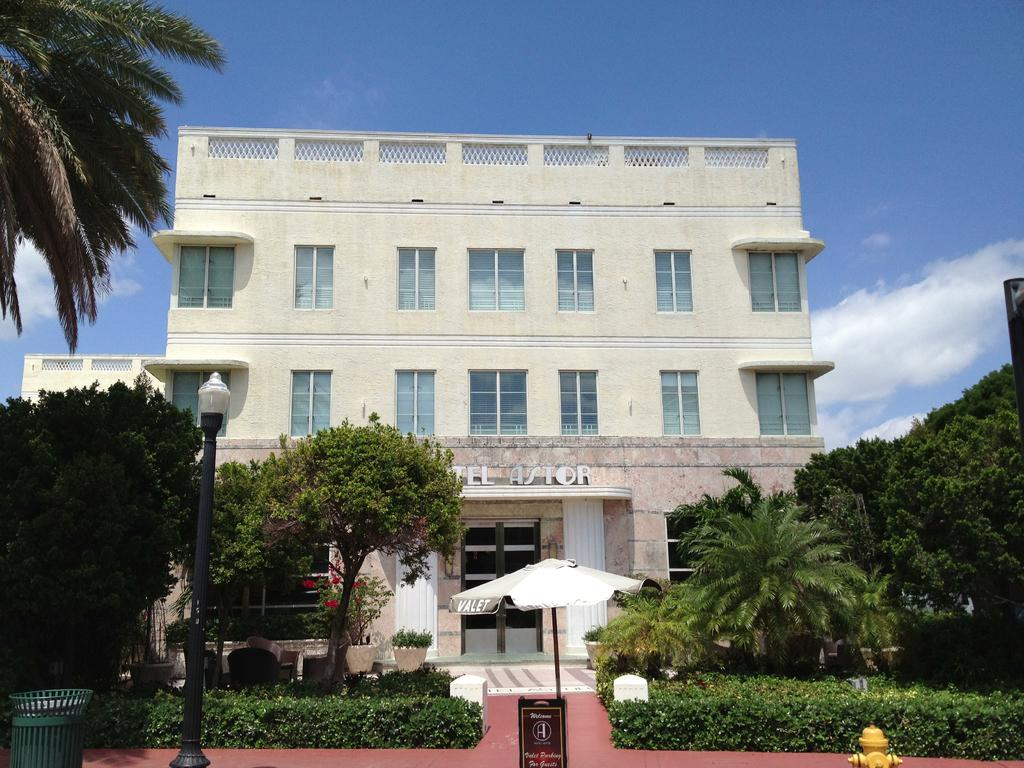<image>
Relay a brief, clear account of the picture shown. Front of Hotel Astor from in front of the host umbrella stand outside. 